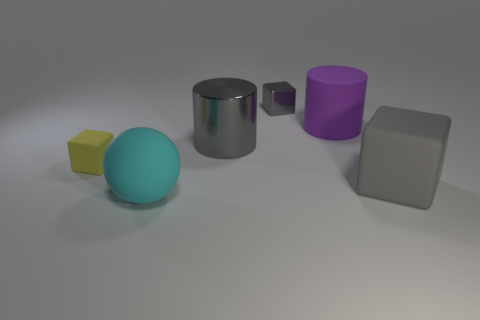Are there any cyan rubber balls to the right of the metal block? I can clearly see a cyan-colored ball, and it is indeed situated to the right of the metal block when viewed from the camera's perspective. 